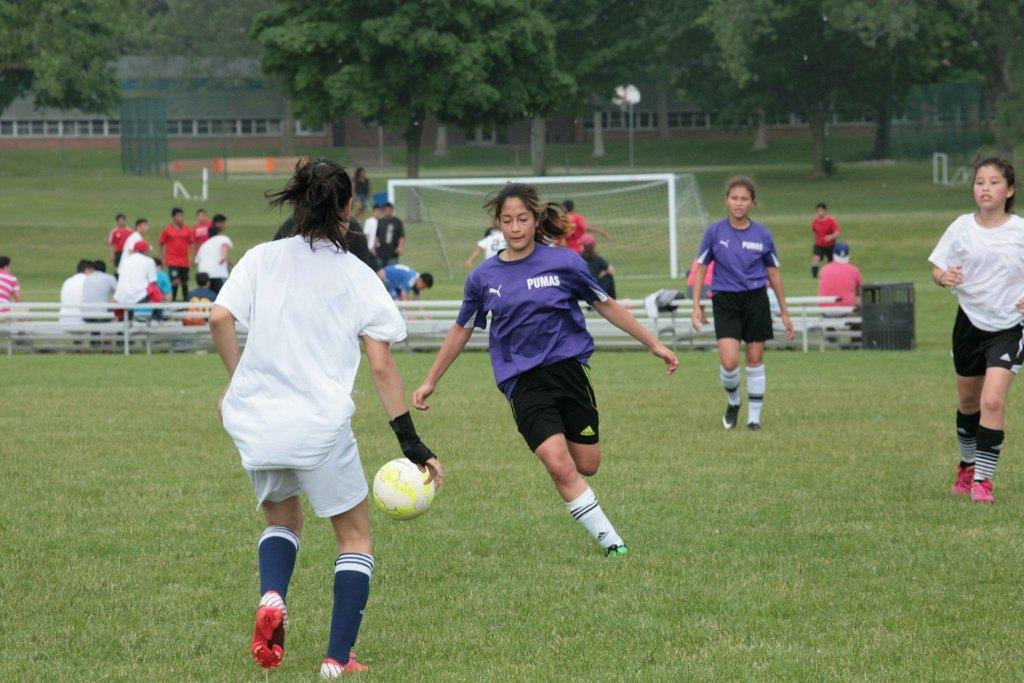<image>
Present a compact description of the photo's key features. A woman in a Pumas shirt goes for the soccer ball with her arms out to her sides. 